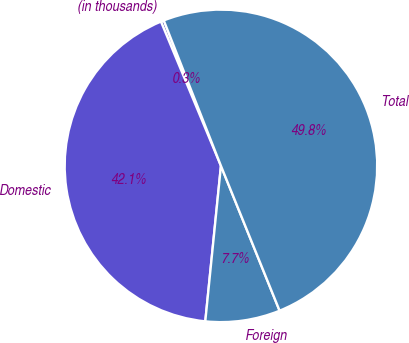Convert chart to OTSL. <chart><loc_0><loc_0><loc_500><loc_500><pie_chart><fcel>(in thousands)<fcel>Domestic<fcel>Foreign<fcel>Total<nl><fcel>0.31%<fcel>42.13%<fcel>7.72%<fcel>49.84%<nl></chart> 